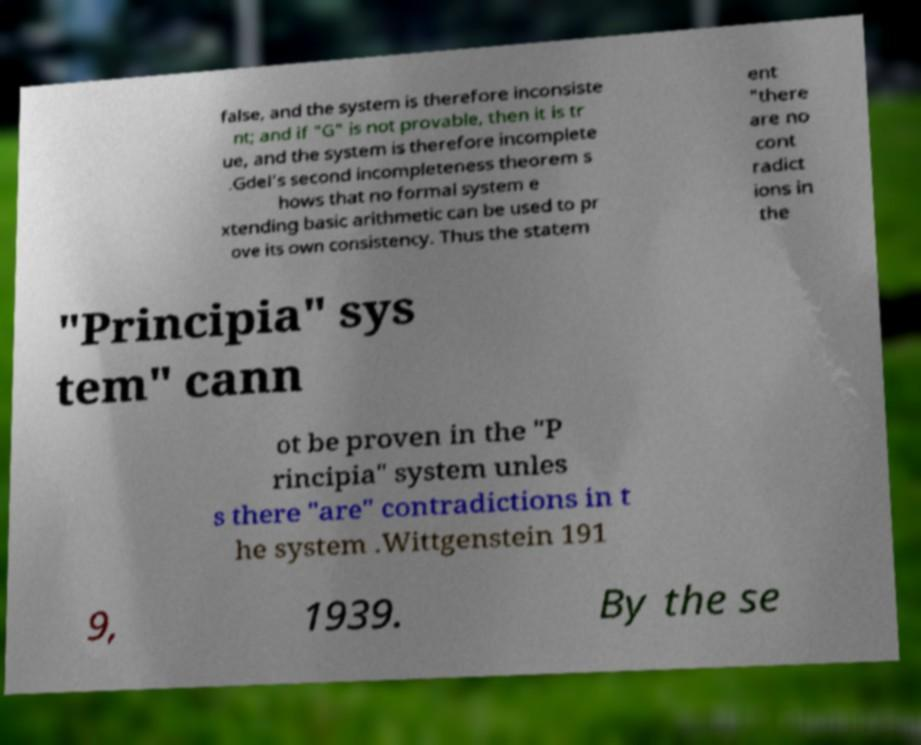Please read and relay the text visible in this image. What does it say? false, and the system is therefore inconsiste nt; and if "G" is not provable, then it is tr ue, and the system is therefore incomplete .Gdel's second incompleteness theorem s hows that no formal system e xtending basic arithmetic can be used to pr ove its own consistency. Thus the statem ent "there are no cont radict ions in the "Principia" sys tem" cann ot be proven in the "P rincipia" system unles s there "are" contradictions in t he system .Wittgenstein 191 9, 1939. By the se 